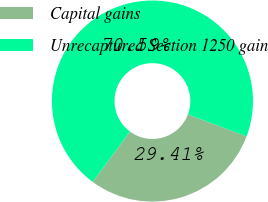<chart> <loc_0><loc_0><loc_500><loc_500><pie_chart><fcel>Capital gains<fcel>Unrecaptured Section 1250 gain<nl><fcel>29.41%<fcel>70.59%<nl></chart> 